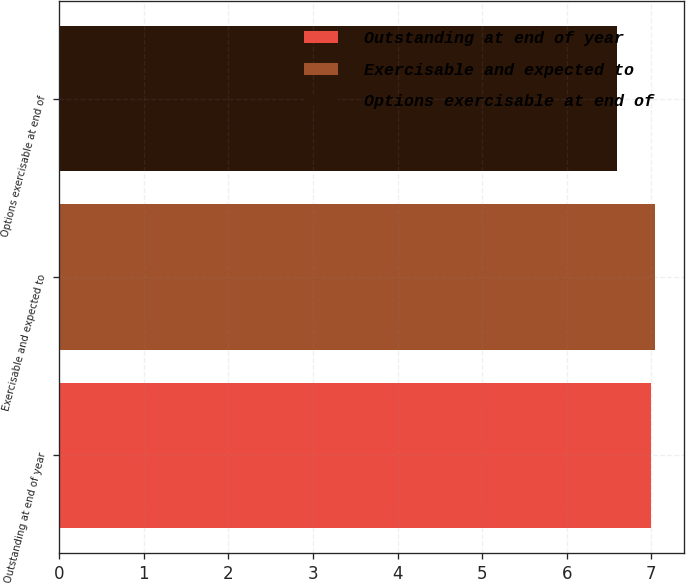Convert chart to OTSL. <chart><loc_0><loc_0><loc_500><loc_500><bar_chart><fcel>Outstanding at end of year<fcel>Exercisable and expected to<fcel>Options exercisable at end of<nl><fcel>7<fcel>7.04<fcel>6.6<nl></chart> 